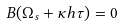<formula> <loc_0><loc_0><loc_500><loc_500>B ( { \Omega } _ { s } + \kappa h { \tau } ) = 0</formula> 